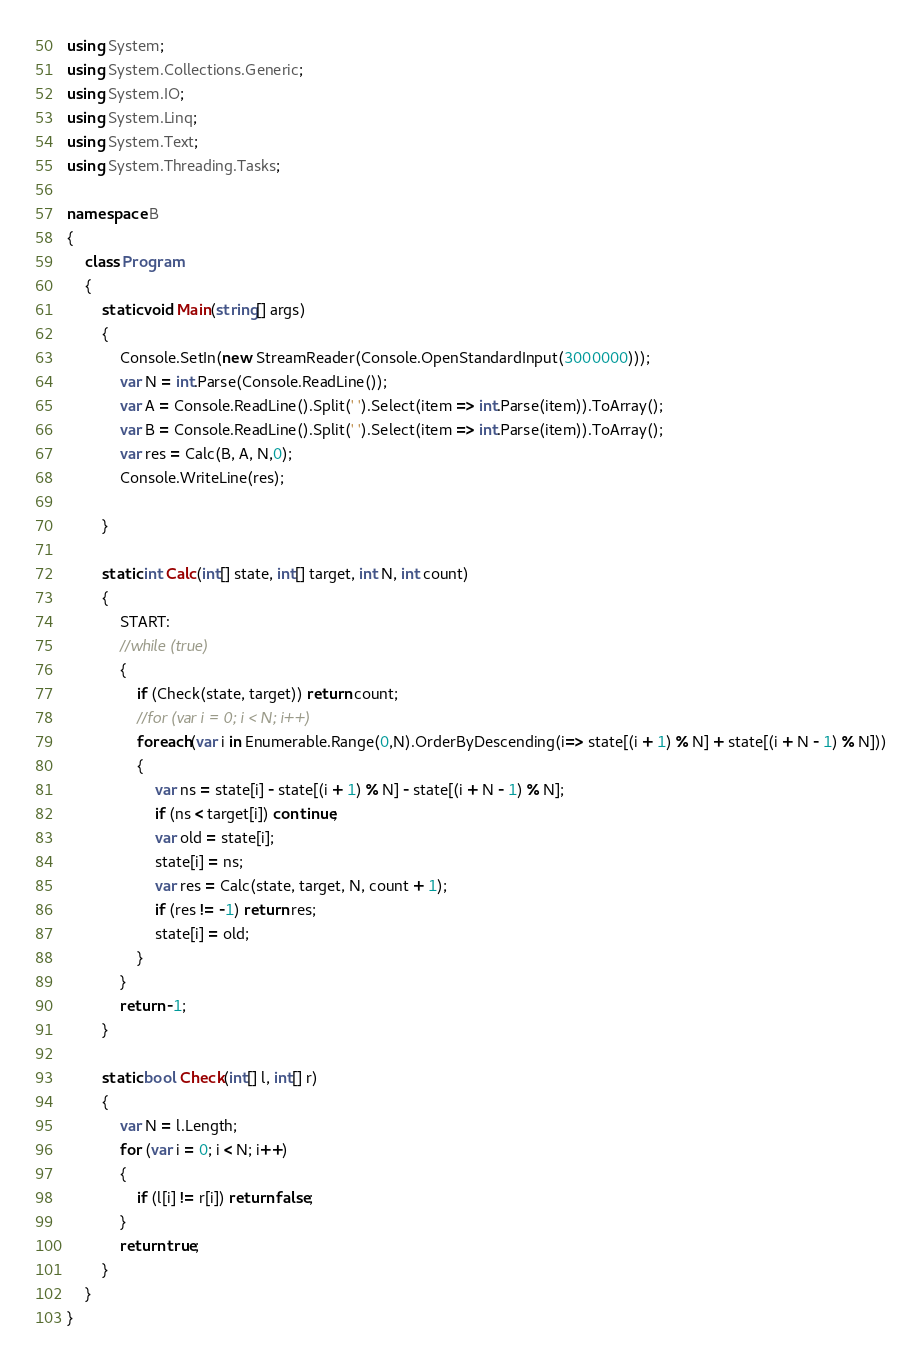Convert code to text. <code><loc_0><loc_0><loc_500><loc_500><_C#_>using System;
using System.Collections.Generic;
using System.IO;
using System.Linq;
using System.Text;
using System.Threading.Tasks;

namespace B
{
    class Program
    {
        static void Main(string[] args)
        {
            Console.SetIn(new StreamReader(Console.OpenStandardInput(3000000)));
            var N = int.Parse(Console.ReadLine());
            var A = Console.ReadLine().Split(' ').Select(item => int.Parse(item)).ToArray();
            var B = Console.ReadLine().Split(' ').Select(item => int.Parse(item)).ToArray();
            var res = Calc(B, A, N,0);
            Console.WriteLine(res);

        }

        static int Calc(int[] state, int[] target, int N, int count)
        {
            START:
            //while (true)
            {
                if (Check(state, target)) return count;
                //for (var i = 0; i < N; i++)
                foreach(var i in Enumerable.Range(0,N).OrderByDescending(i=> state[(i + 1) % N] + state[(i + N - 1) % N]))
                {
                    var ns = state[i] - state[(i + 1) % N] - state[(i + N - 1) % N];
                    if (ns < target[i]) continue;
                    var old = state[i];
                    state[i] = ns;
                    var res = Calc(state, target, N, count + 1);
                    if (res != -1) return res;
                    state[i] = old;
                }
            }
            return -1;
        }

        static bool Check(int[] l, int[] r)
        {
            var N = l.Length;
            for (var i = 0; i < N; i++)
            {
                if (l[i] != r[i]) return false;
            }
            return true;
        }
    }
}
</code> 